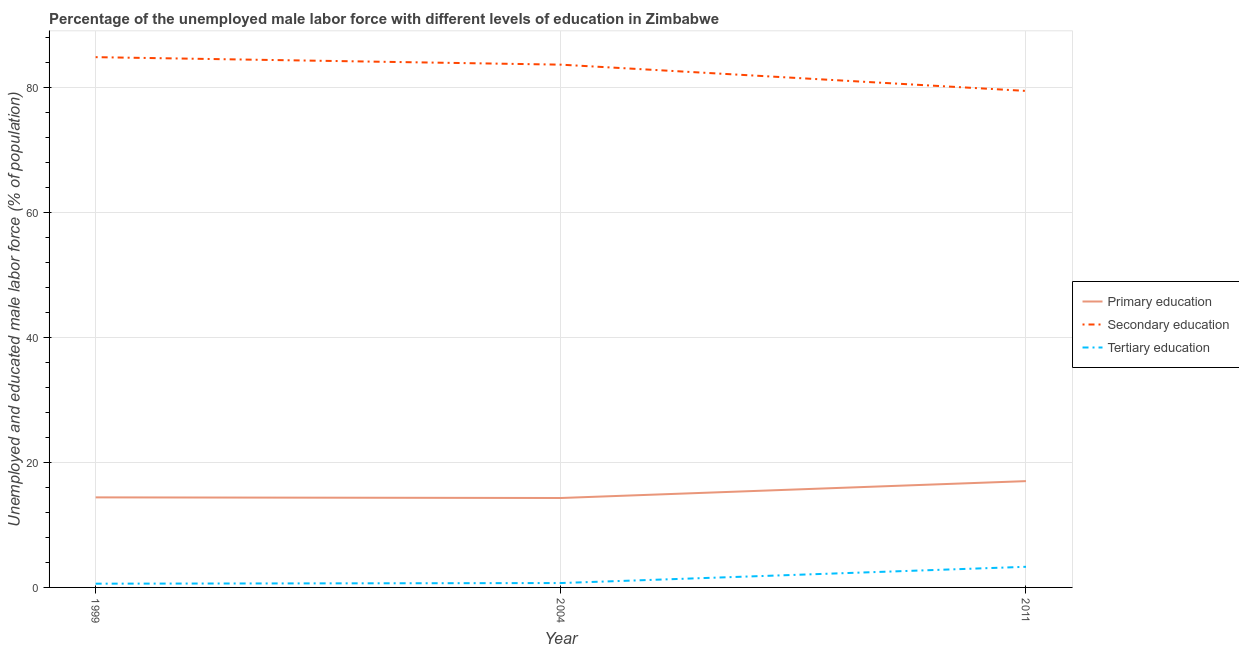Does the line corresponding to percentage of male labor force who received primary education intersect with the line corresponding to percentage of male labor force who received secondary education?
Offer a very short reply. No. Is the number of lines equal to the number of legend labels?
Provide a short and direct response. Yes. What is the percentage of male labor force who received secondary education in 2011?
Offer a terse response. 79.4. Across all years, what is the maximum percentage of male labor force who received tertiary education?
Offer a very short reply. 3.3. Across all years, what is the minimum percentage of male labor force who received tertiary education?
Provide a short and direct response. 0.6. In which year was the percentage of male labor force who received primary education maximum?
Your response must be concise. 2011. What is the total percentage of male labor force who received tertiary education in the graph?
Provide a short and direct response. 4.6. What is the difference between the percentage of male labor force who received tertiary education in 2004 and that in 2011?
Offer a terse response. -2.6. What is the difference between the percentage of male labor force who received primary education in 1999 and the percentage of male labor force who received tertiary education in 2004?
Ensure brevity in your answer.  13.7. What is the average percentage of male labor force who received tertiary education per year?
Ensure brevity in your answer.  1.53. In the year 1999, what is the difference between the percentage of male labor force who received secondary education and percentage of male labor force who received primary education?
Make the answer very short. 70.4. What is the ratio of the percentage of male labor force who received tertiary education in 2004 to that in 2011?
Your answer should be compact. 0.21. Is the percentage of male labor force who received tertiary education in 1999 less than that in 2011?
Provide a short and direct response. Yes. Is the difference between the percentage of male labor force who received tertiary education in 1999 and 2004 greater than the difference between the percentage of male labor force who received secondary education in 1999 and 2004?
Your response must be concise. No. What is the difference between the highest and the second highest percentage of male labor force who received secondary education?
Your answer should be compact. 1.2. What is the difference between the highest and the lowest percentage of male labor force who received secondary education?
Provide a short and direct response. 5.4. In how many years, is the percentage of male labor force who received primary education greater than the average percentage of male labor force who received primary education taken over all years?
Your answer should be compact. 1. Is the sum of the percentage of male labor force who received tertiary education in 1999 and 2004 greater than the maximum percentage of male labor force who received primary education across all years?
Provide a short and direct response. No. Is it the case that in every year, the sum of the percentage of male labor force who received primary education and percentage of male labor force who received secondary education is greater than the percentage of male labor force who received tertiary education?
Ensure brevity in your answer.  Yes. Does the percentage of male labor force who received secondary education monotonically increase over the years?
Ensure brevity in your answer.  No. Is the percentage of male labor force who received tertiary education strictly greater than the percentage of male labor force who received secondary education over the years?
Ensure brevity in your answer.  No. Is the percentage of male labor force who received primary education strictly less than the percentage of male labor force who received secondary education over the years?
Give a very brief answer. Yes. How many years are there in the graph?
Ensure brevity in your answer.  3. What is the difference between two consecutive major ticks on the Y-axis?
Provide a succinct answer. 20. Are the values on the major ticks of Y-axis written in scientific E-notation?
Your answer should be compact. No. Does the graph contain any zero values?
Your answer should be compact. No. Does the graph contain grids?
Ensure brevity in your answer.  Yes. Where does the legend appear in the graph?
Make the answer very short. Center right. What is the title of the graph?
Provide a succinct answer. Percentage of the unemployed male labor force with different levels of education in Zimbabwe. Does "Ages 15-64" appear as one of the legend labels in the graph?
Your answer should be compact. No. What is the label or title of the X-axis?
Provide a succinct answer. Year. What is the label or title of the Y-axis?
Keep it short and to the point. Unemployed and educated male labor force (% of population). What is the Unemployed and educated male labor force (% of population) of Primary education in 1999?
Provide a succinct answer. 14.4. What is the Unemployed and educated male labor force (% of population) in Secondary education in 1999?
Ensure brevity in your answer.  84.8. What is the Unemployed and educated male labor force (% of population) of Tertiary education in 1999?
Offer a terse response. 0.6. What is the Unemployed and educated male labor force (% of population) of Primary education in 2004?
Your response must be concise. 14.3. What is the Unemployed and educated male labor force (% of population) in Secondary education in 2004?
Your answer should be compact. 83.6. What is the Unemployed and educated male labor force (% of population) of Tertiary education in 2004?
Keep it short and to the point. 0.7. What is the Unemployed and educated male labor force (% of population) of Secondary education in 2011?
Offer a very short reply. 79.4. What is the Unemployed and educated male labor force (% of population) of Tertiary education in 2011?
Offer a very short reply. 3.3. Across all years, what is the maximum Unemployed and educated male labor force (% of population) in Secondary education?
Provide a short and direct response. 84.8. Across all years, what is the maximum Unemployed and educated male labor force (% of population) in Tertiary education?
Provide a succinct answer. 3.3. Across all years, what is the minimum Unemployed and educated male labor force (% of population) of Primary education?
Your answer should be compact. 14.3. Across all years, what is the minimum Unemployed and educated male labor force (% of population) of Secondary education?
Make the answer very short. 79.4. Across all years, what is the minimum Unemployed and educated male labor force (% of population) in Tertiary education?
Give a very brief answer. 0.6. What is the total Unemployed and educated male labor force (% of population) in Primary education in the graph?
Give a very brief answer. 45.7. What is the total Unemployed and educated male labor force (% of population) in Secondary education in the graph?
Your response must be concise. 247.8. What is the total Unemployed and educated male labor force (% of population) in Tertiary education in the graph?
Offer a terse response. 4.6. What is the difference between the Unemployed and educated male labor force (% of population) in Secondary education in 1999 and that in 2004?
Give a very brief answer. 1.2. What is the difference between the Unemployed and educated male labor force (% of population) in Primary education in 1999 and that in 2011?
Ensure brevity in your answer.  -2.6. What is the difference between the Unemployed and educated male labor force (% of population) in Secondary education in 1999 and that in 2011?
Your response must be concise. 5.4. What is the difference between the Unemployed and educated male labor force (% of population) of Secondary education in 2004 and that in 2011?
Offer a very short reply. 4.2. What is the difference between the Unemployed and educated male labor force (% of population) of Tertiary education in 2004 and that in 2011?
Give a very brief answer. -2.6. What is the difference between the Unemployed and educated male labor force (% of population) in Primary education in 1999 and the Unemployed and educated male labor force (% of population) in Secondary education in 2004?
Your answer should be very brief. -69.2. What is the difference between the Unemployed and educated male labor force (% of population) of Secondary education in 1999 and the Unemployed and educated male labor force (% of population) of Tertiary education in 2004?
Provide a short and direct response. 84.1. What is the difference between the Unemployed and educated male labor force (% of population) in Primary education in 1999 and the Unemployed and educated male labor force (% of population) in Secondary education in 2011?
Your answer should be compact. -65. What is the difference between the Unemployed and educated male labor force (% of population) in Secondary education in 1999 and the Unemployed and educated male labor force (% of population) in Tertiary education in 2011?
Keep it short and to the point. 81.5. What is the difference between the Unemployed and educated male labor force (% of population) of Primary education in 2004 and the Unemployed and educated male labor force (% of population) of Secondary education in 2011?
Ensure brevity in your answer.  -65.1. What is the difference between the Unemployed and educated male labor force (% of population) in Secondary education in 2004 and the Unemployed and educated male labor force (% of population) in Tertiary education in 2011?
Offer a very short reply. 80.3. What is the average Unemployed and educated male labor force (% of population) of Primary education per year?
Provide a short and direct response. 15.23. What is the average Unemployed and educated male labor force (% of population) in Secondary education per year?
Offer a very short reply. 82.6. What is the average Unemployed and educated male labor force (% of population) of Tertiary education per year?
Offer a very short reply. 1.53. In the year 1999, what is the difference between the Unemployed and educated male labor force (% of population) in Primary education and Unemployed and educated male labor force (% of population) in Secondary education?
Your answer should be compact. -70.4. In the year 1999, what is the difference between the Unemployed and educated male labor force (% of population) of Primary education and Unemployed and educated male labor force (% of population) of Tertiary education?
Provide a succinct answer. 13.8. In the year 1999, what is the difference between the Unemployed and educated male labor force (% of population) in Secondary education and Unemployed and educated male labor force (% of population) in Tertiary education?
Ensure brevity in your answer.  84.2. In the year 2004, what is the difference between the Unemployed and educated male labor force (% of population) of Primary education and Unemployed and educated male labor force (% of population) of Secondary education?
Provide a succinct answer. -69.3. In the year 2004, what is the difference between the Unemployed and educated male labor force (% of population) of Secondary education and Unemployed and educated male labor force (% of population) of Tertiary education?
Your answer should be compact. 82.9. In the year 2011, what is the difference between the Unemployed and educated male labor force (% of population) in Primary education and Unemployed and educated male labor force (% of population) in Secondary education?
Your response must be concise. -62.4. In the year 2011, what is the difference between the Unemployed and educated male labor force (% of population) of Primary education and Unemployed and educated male labor force (% of population) of Tertiary education?
Give a very brief answer. 13.7. In the year 2011, what is the difference between the Unemployed and educated male labor force (% of population) in Secondary education and Unemployed and educated male labor force (% of population) in Tertiary education?
Ensure brevity in your answer.  76.1. What is the ratio of the Unemployed and educated male labor force (% of population) in Primary education in 1999 to that in 2004?
Keep it short and to the point. 1.01. What is the ratio of the Unemployed and educated male labor force (% of population) in Secondary education in 1999 to that in 2004?
Ensure brevity in your answer.  1.01. What is the ratio of the Unemployed and educated male labor force (% of population) in Tertiary education in 1999 to that in 2004?
Your answer should be compact. 0.86. What is the ratio of the Unemployed and educated male labor force (% of population) of Primary education in 1999 to that in 2011?
Your answer should be compact. 0.85. What is the ratio of the Unemployed and educated male labor force (% of population) in Secondary education in 1999 to that in 2011?
Give a very brief answer. 1.07. What is the ratio of the Unemployed and educated male labor force (% of population) of Tertiary education in 1999 to that in 2011?
Offer a terse response. 0.18. What is the ratio of the Unemployed and educated male labor force (% of population) of Primary education in 2004 to that in 2011?
Offer a very short reply. 0.84. What is the ratio of the Unemployed and educated male labor force (% of population) in Secondary education in 2004 to that in 2011?
Provide a short and direct response. 1.05. What is the ratio of the Unemployed and educated male labor force (% of population) of Tertiary education in 2004 to that in 2011?
Offer a terse response. 0.21. What is the difference between the highest and the second highest Unemployed and educated male labor force (% of population) of Secondary education?
Make the answer very short. 1.2. What is the difference between the highest and the lowest Unemployed and educated male labor force (% of population) in Primary education?
Your answer should be very brief. 2.7. 